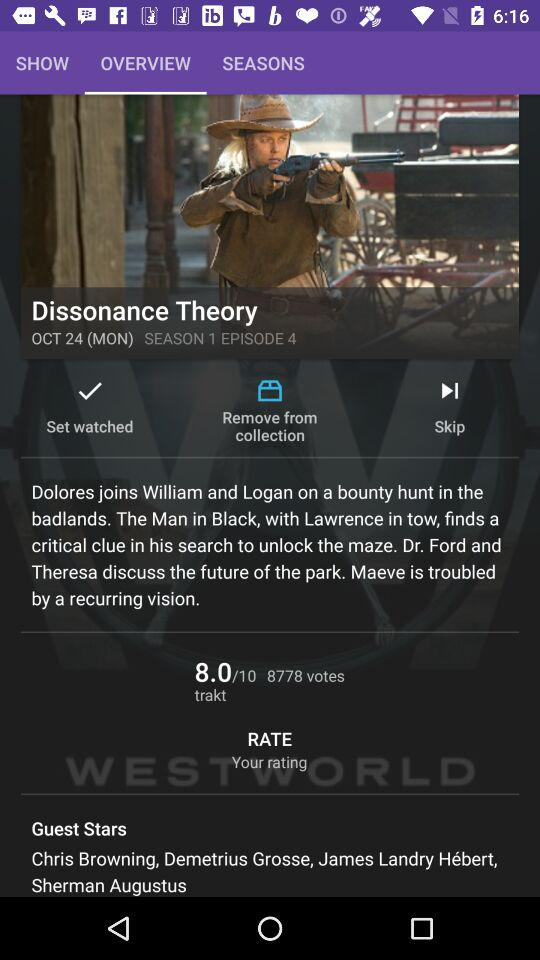What is the day on 24 Oct.? The day on 24 Oct. is Monday. 